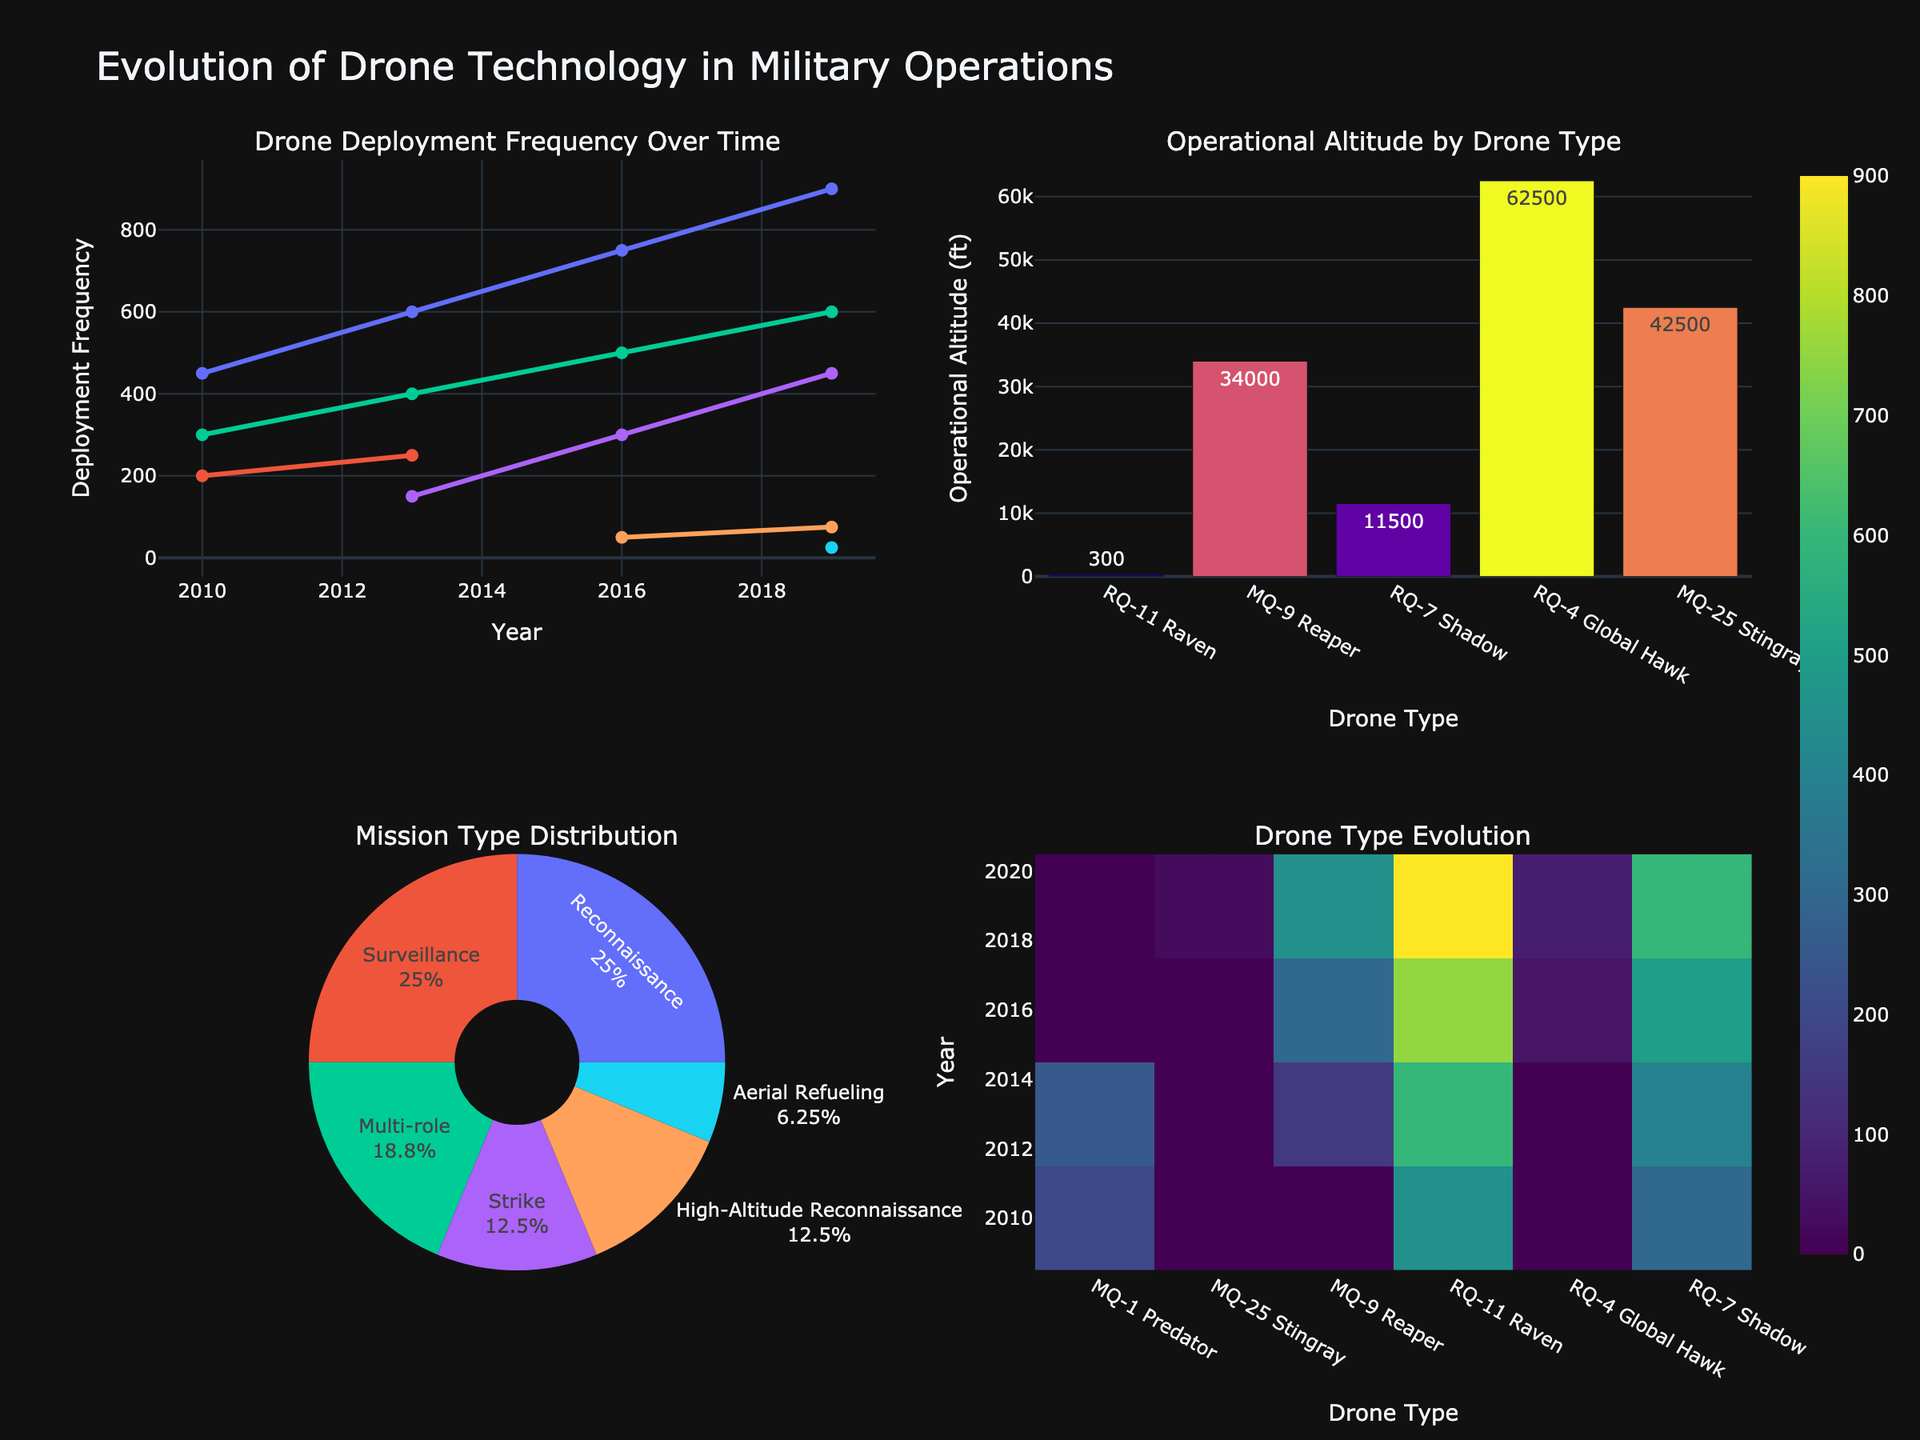What is the country with the highest job opportunities in Software engineering? From the grid of subplots, locate the bar plot for Software specialization. Observe the height of the bars and find the one that is tallest. USA has the tallest bar for Software engineering.
Answer: USA Which specialization has the lowest number of job opportunities in Japan? From each subplot, locate the bar representing Japan and compare their heights. The shortest bar among them is for Biomedical specialization.
Answer: Biomedical What is the overall trend for Mechanical engineering job opportunities across the countries? Examine the bar plot for Mechanical specialization and compare the heights of the bars for each country. Notice that the highest job opportunities are in China, followed by USA and Germany, with the lowest in Canada.
Answer: High in China, moderate in USA and Germany, low in Canada Which country has more job opportunities in Electrical engineering, Germany or India? From the subplot of Electrical specialization, compare the bars representing Germany and India. The bar for India is taller.
Answer: India What is the difference in job opportunities for Biomedical engineering between UK and Canada? Locate the bar plot for Biomedical specialization and note the heights of the bars for UK and Canada. Subtract the value of the Canadian bar from the UK bar (7 - 4).
Answer: 3 Which specialization has more job opportunities in Canada, Aerospace or Civil? Compare the heights of the bars in the subplots for Aerospace and Civil specializations for Canada. The bar for Civil is taller.
Answer: Civil What is the sum of job opportunities for Chemical engineering in USA and Japan? Locate the bar plot for Chemical specialization and sum the values of the bars for USA and Japan (15 + 10).
Answer: 25 Are job opportunities for Environmental engineering greater in India than in Germany? Compare the bars for Environmental specialization in India and Germany. The German bar is taller.
Answer: No Which country offers the highest job opportunities for Civil engineering? Observe the bar plot for Civil specialization and find the tallest bar, which represents India.
Answer: India 